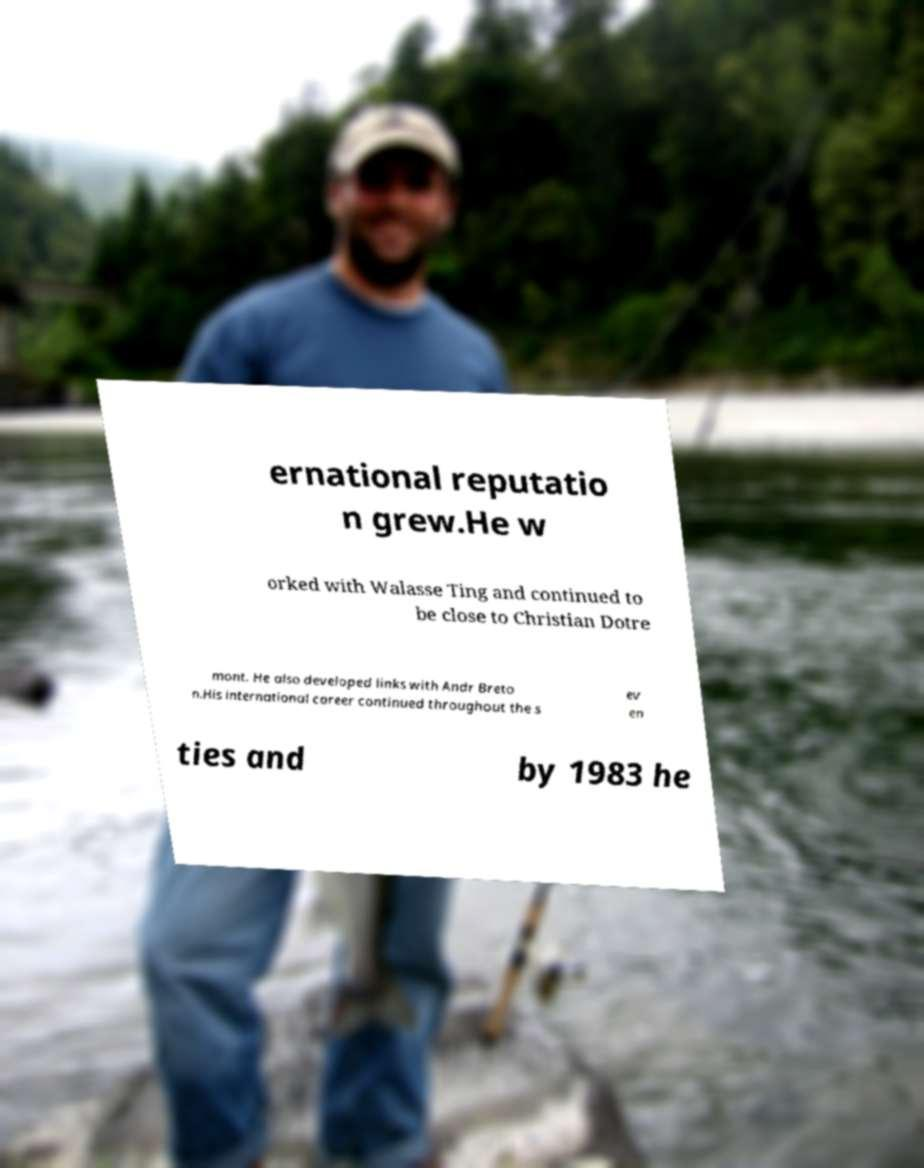What messages or text are displayed in this image? I need them in a readable, typed format. ernational reputatio n grew.He w orked with Walasse Ting and continued to be close to Christian Dotre mont. He also developed links with Andr Breto n.His international career continued throughout the s ev en ties and by 1983 he 